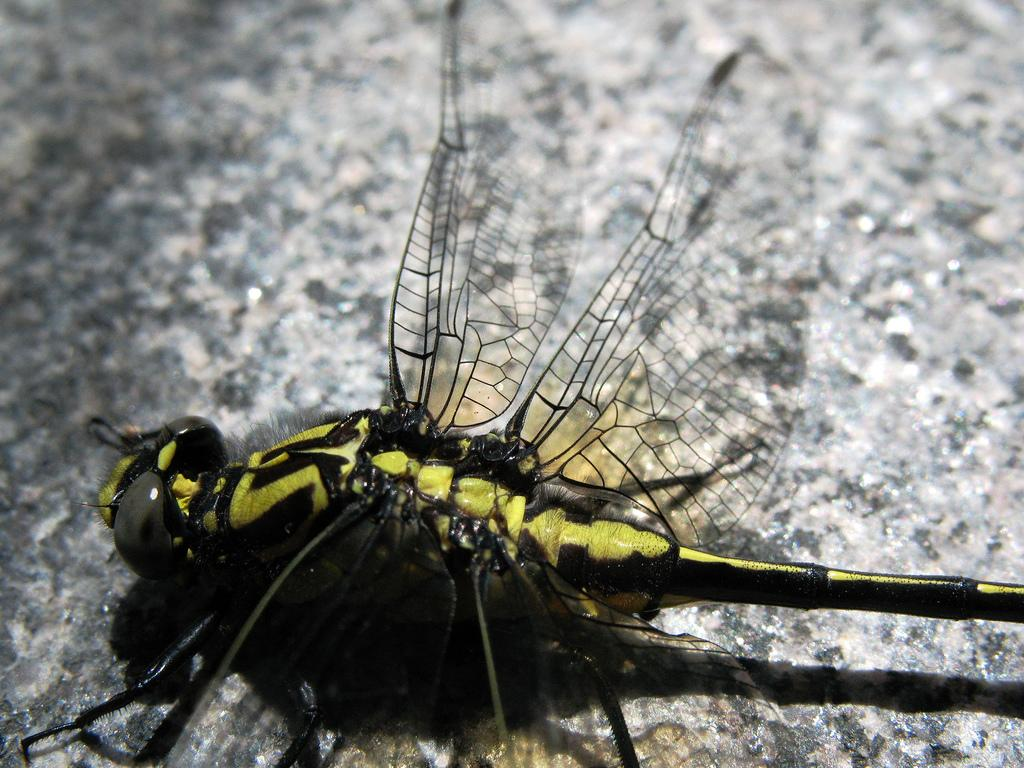What type of creature is present in the image? There is an insect in the image. Where is the insect located in the image? The insect is on a surface. What type of dock can be seen in the image? There is no dock present in the image; it only features an insect on a surface. What type of orange is visible in the image? There is no orange present in the image; it only features an insect on a surface. 